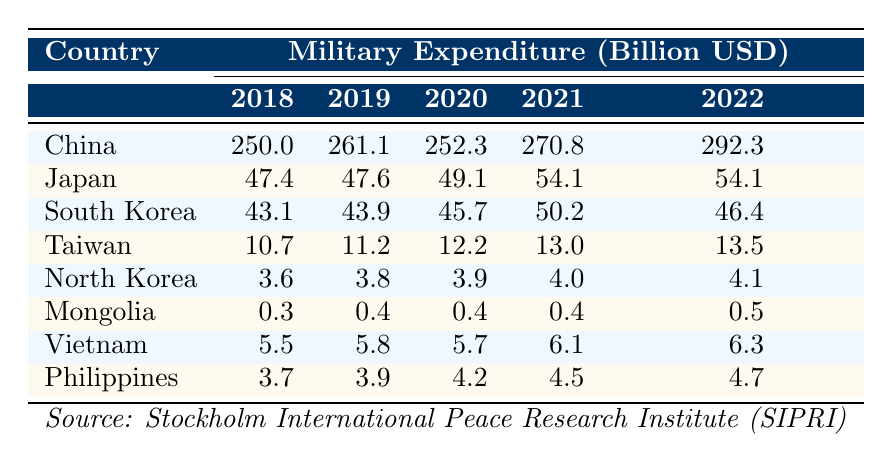What was the military expenditure of China in 2021? From the table, China’s military expenditure in 2021 is clearly stated as 270.8 billion USD.
Answer: 270.8 billion USD Which country had the lowest military expenditure in 2022? The data shows the military expenditures in 2022: China (292.3), Japan (54.1), South Korea (46.4), Taiwan (13.5), North Korea (4.1), Mongolia (0.5), Vietnam (6.3), and Philippines (4.7). The lowest value is for Mongolia at 0.5 billion USD.
Answer: Mongolia What is the total military expenditure of Japan from 2018 to 2022? Adding Japan's expenditures for each year: 47.4 + 47.6 + 49.1 + 54.1 + 54.1 gives a total of 252.3 billion USD.
Answer: 252.3 billion USD Did South Korea's military expenditure increase in 2020 compared to 2019? The expenditures are 43.9 billion USD for 2019 and 45.7 billion USD for 2020. Since 45.7 is greater than 43.9, the expenditure did increase.
Answer: Yes What is the average military expenditure for the Philippines over the years 2018 to 2022? To find the average, sum the expenditures: 3.7 + 3.9 + 4.2 + 4.5 + 4.7 = 20.9 billion USD. Then, divide by 5 (the number of years): 20.9 / 5 = 4.18 billion USD.
Answer: 4.18 billion USD Which country increased its military expenditure by the largest amount from 2018 to 2022? The differences are calculated as follows: China: 292.3 - 250.0 = 42.3, Japan: 54.1 - 47.4 = 6.7, South Korea: 46.4 - 43.1 = 3.3, Taiwan: 13.5 - 10.7 = 2.8, North Korea: 4.1 - 3.6 = 0.5, Mongolia: 0.5 - 0.3 = 0.2, Vietnam: 6.3 - 5.5 = 0.8, Philippines: 4.7 - 3.7 = 1.0. The largest increase is from China, 42.3 billion USD.
Answer: China Did Japan's military expenditure decrease at any point during the years 2018 to 2022? Comparing the annual values, Japan's expenditures were: 47.4, 47.6, 49.1, 54.1, 54.1. Since all values show an increase or remain constant, the answer is no.
Answer: No What was the difference in military expenditure between North Korea and Vietnam in 2021? In 2021, North Korea spent 4.0 billion USD, while Vietnam spent 6.1 billion USD. The difference is 6.1 - 4.0 = 2.1 billion USD.
Answer: 2.1 billion USD 